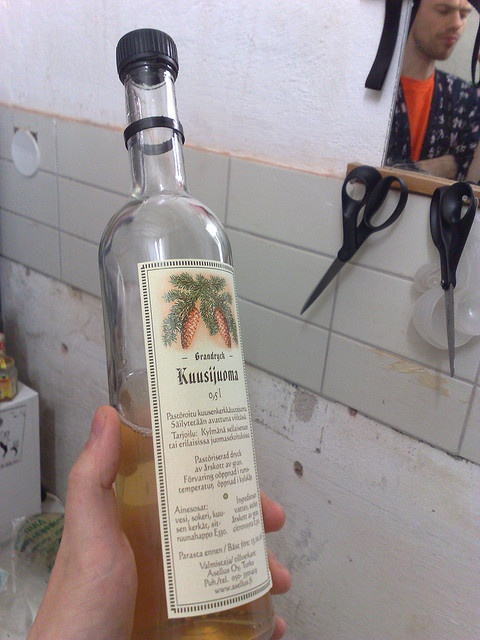Describe the objects in this image and their specific colors. I can see bottle in lavender, darkgray, lightgray, and gray tones, people in lavender, gray, salmon, and brown tones, scissors in lavender, black, and gray tones, and scissors in lavender, black, and gray tones in this image. 